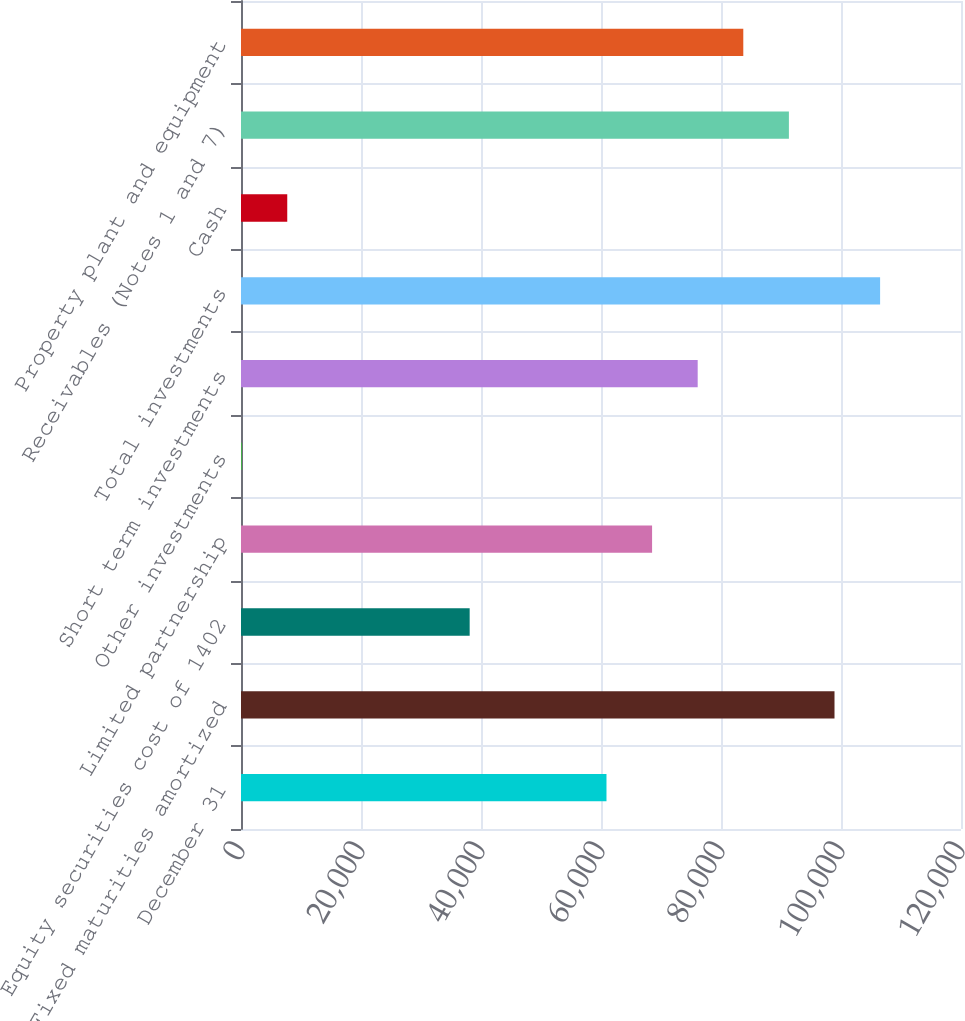Convert chart. <chart><loc_0><loc_0><loc_500><loc_500><bar_chart><fcel>December 31<fcel>Fixed maturities amortized<fcel>Equity securities cost of 1402<fcel>Limited partnership<fcel>Other investments<fcel>Short term investments<fcel>Total investments<fcel>Cash<fcel>Receivables (Notes 1 and 7)<fcel>Property plant and equipment<nl><fcel>60913.6<fcel>98917.1<fcel>38111.5<fcel>68514.3<fcel>108<fcel>76115<fcel>106518<fcel>7708.7<fcel>91316.4<fcel>83715.7<nl></chart> 